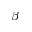Convert formula to latex. <formula><loc_0><loc_0><loc_500><loc_500>\beta</formula> 